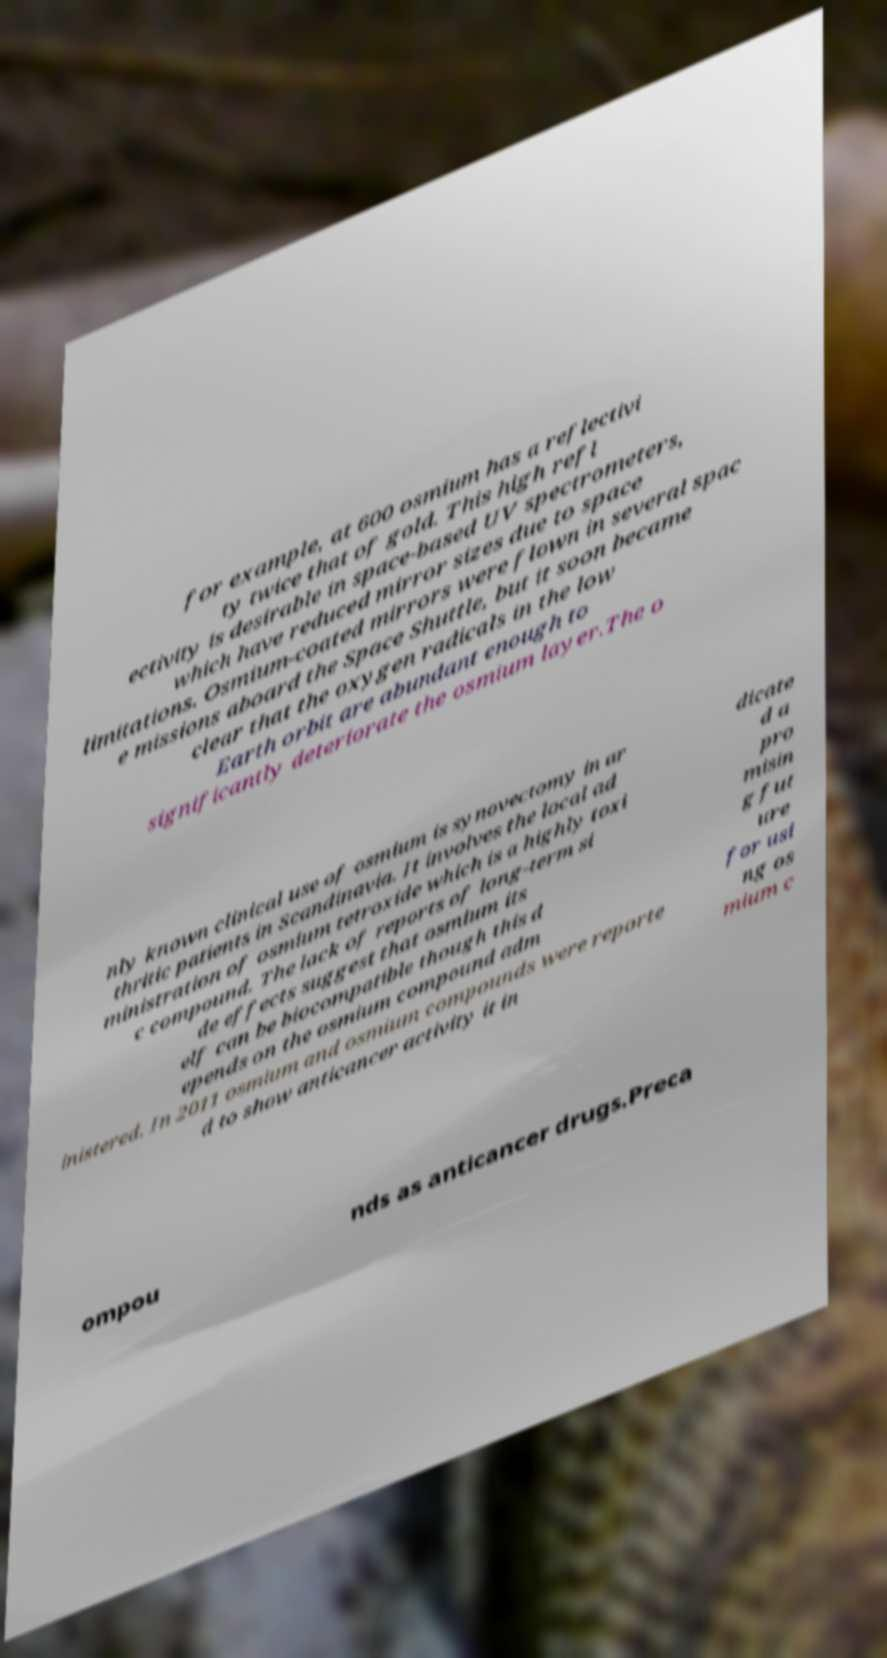Please read and relay the text visible in this image. What does it say? for example, at 600 osmium has a reflectivi ty twice that of gold. This high refl ectivity is desirable in space-based UV spectrometers, which have reduced mirror sizes due to space limitations. Osmium-coated mirrors were flown in several spac e missions aboard the Space Shuttle, but it soon became clear that the oxygen radicals in the low Earth orbit are abundant enough to significantly deteriorate the osmium layer.The o nly known clinical use of osmium is synovectomy in ar thritic patients in Scandinavia. It involves the local ad ministration of osmium tetroxide which is a highly toxi c compound. The lack of reports of long-term si de effects suggest that osmium its elf can be biocompatible though this d epends on the osmium compound adm inistered. In 2011 osmium and osmium compounds were reporte d to show anticancer activity it in dicate d a pro misin g fut ure for usi ng os mium c ompou nds as anticancer drugs.Preca 